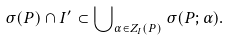<formula> <loc_0><loc_0><loc_500><loc_500>\sigma ( P ) \cap I ^ { \prime } \subset \bigcup \nolimits _ { \alpha \in Z _ { I } ( P ) } \sigma ( P ; \alpha ) .</formula> 